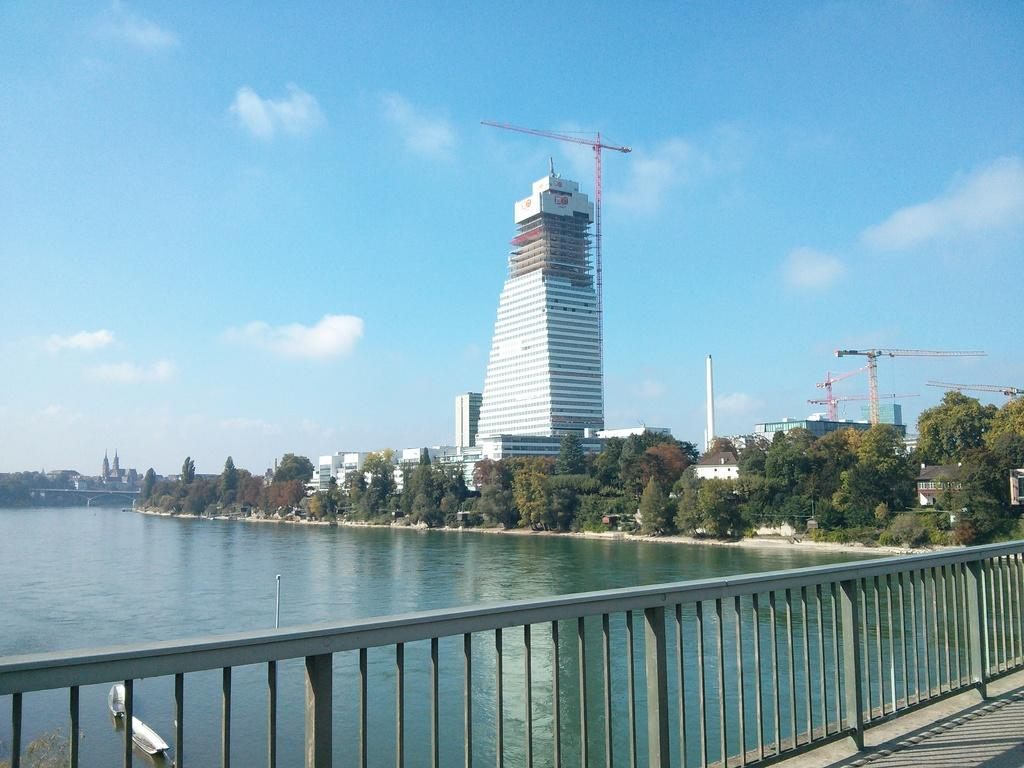What type of structure can be seen in the image? There is a fence in the image. What natural element is visible in the image? There is water visible in the image. What can be seen in the background of the image? There are trees, buildings, and cranes in the background of the image. What part of the natural environment is visible in the image? The sky is visible in the background of the image. How many daughters can be seen playing with ants in the image? There are no daughters or ants present in the image. What finger is pointing at the cranes in the image? There are no fingers visible in the image, and no one is pointing at the cranes. 